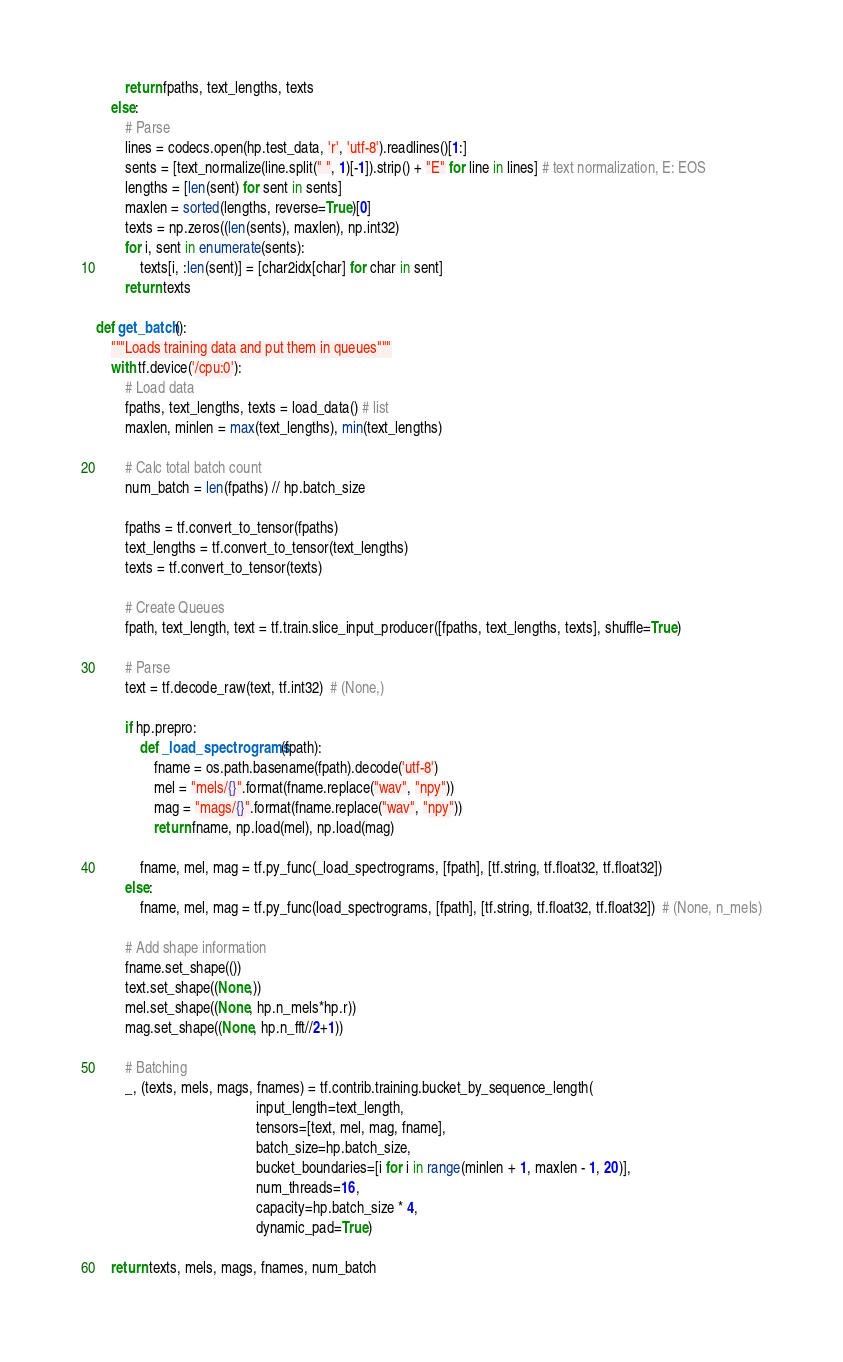Convert code to text. <code><loc_0><loc_0><loc_500><loc_500><_Python_>        return fpaths, text_lengths, texts
    else:
        # Parse
        lines = codecs.open(hp.test_data, 'r', 'utf-8').readlines()[1:]
        sents = [text_normalize(line.split(" ", 1)[-1]).strip() + "E" for line in lines] # text normalization, E: EOS
        lengths = [len(sent) for sent in sents]
        maxlen = sorted(lengths, reverse=True)[0]
        texts = np.zeros((len(sents), maxlen), np.int32)
        for i, sent in enumerate(sents):
            texts[i, :len(sent)] = [char2idx[char] for char in sent]
        return texts

def get_batch():
    """Loads training data and put them in queues"""
    with tf.device('/cpu:0'):
        # Load data
        fpaths, text_lengths, texts = load_data() # list
        maxlen, minlen = max(text_lengths), min(text_lengths)

        # Calc total batch count
        num_batch = len(fpaths) // hp.batch_size

        fpaths = tf.convert_to_tensor(fpaths)
        text_lengths = tf.convert_to_tensor(text_lengths)
        texts = tf.convert_to_tensor(texts)

        # Create Queues
        fpath, text_length, text = tf.train.slice_input_producer([fpaths, text_lengths, texts], shuffle=True)

        # Parse
        text = tf.decode_raw(text, tf.int32)  # (None,)

        if hp.prepro:
            def _load_spectrograms(fpath):
                fname = os.path.basename(fpath).decode('utf-8')
                mel = "mels/{}".format(fname.replace("wav", "npy"))
                mag = "mags/{}".format(fname.replace("wav", "npy"))
                return fname, np.load(mel), np.load(mag)

            fname, mel, mag = tf.py_func(_load_spectrograms, [fpath], [tf.string, tf.float32, tf.float32])
        else:
            fname, mel, mag = tf.py_func(load_spectrograms, [fpath], [tf.string, tf.float32, tf.float32])  # (None, n_mels)

        # Add shape information
        fname.set_shape(())
        text.set_shape((None,))
        mel.set_shape((None, hp.n_mels*hp.r))
        mag.set_shape((None, hp.n_fft//2+1))

        # Batching
        _, (texts, mels, mags, fnames) = tf.contrib.training.bucket_by_sequence_length(
                                            input_length=text_length,
                                            tensors=[text, mel, mag, fname],
                                            batch_size=hp.batch_size,
                                            bucket_boundaries=[i for i in range(minlen + 1, maxlen - 1, 20)],
                                            num_threads=16,
                                            capacity=hp.batch_size * 4,
                                            dynamic_pad=True)

    return texts, mels, mags, fnames, num_batch

</code> 